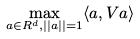Convert formula to latex. <formula><loc_0><loc_0><loc_500><loc_500>\max _ { a \in R ^ { d } , | | a | | = 1 } \langle a , V a \rangle</formula> 